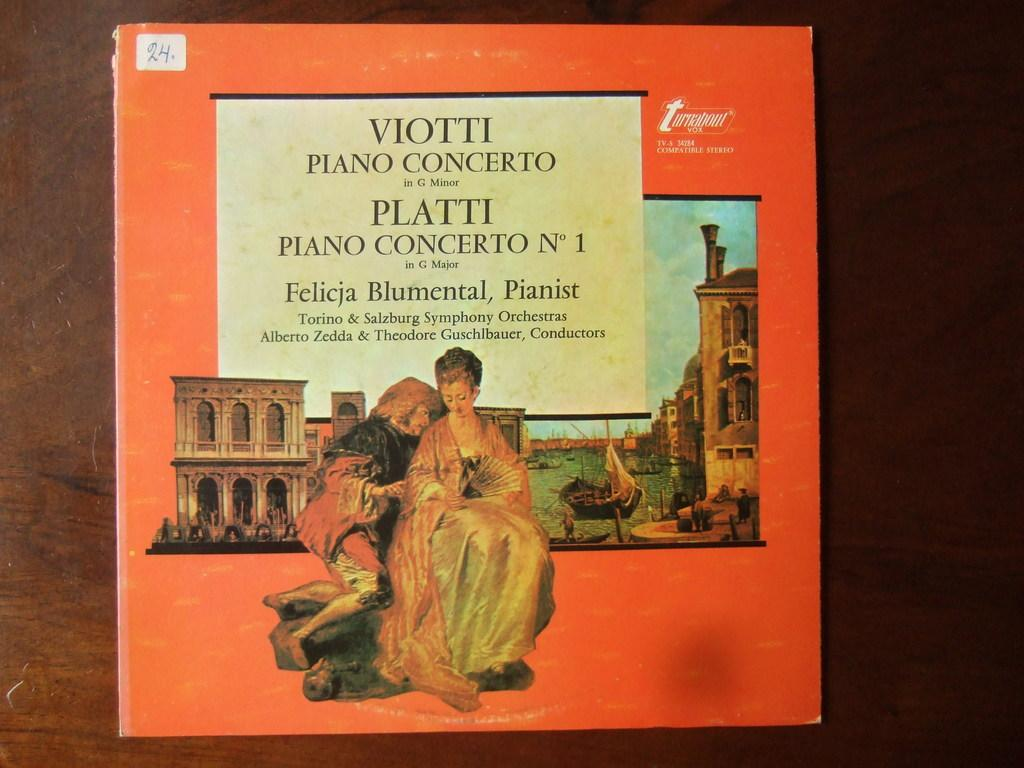<image>
Summarize the visual content of the image. The record jacket describes two piano concertos, Viotti and Platti. 